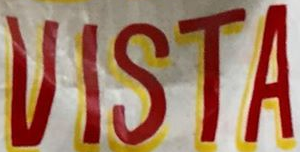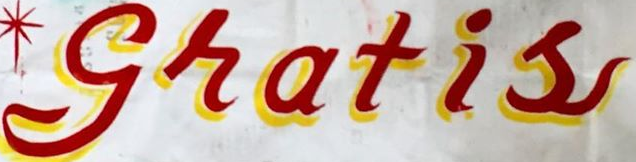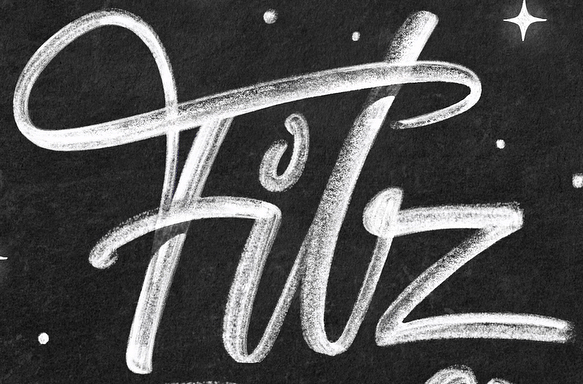Read the text from these images in sequence, separated by a semicolon. VISTA; gratis; Filz 